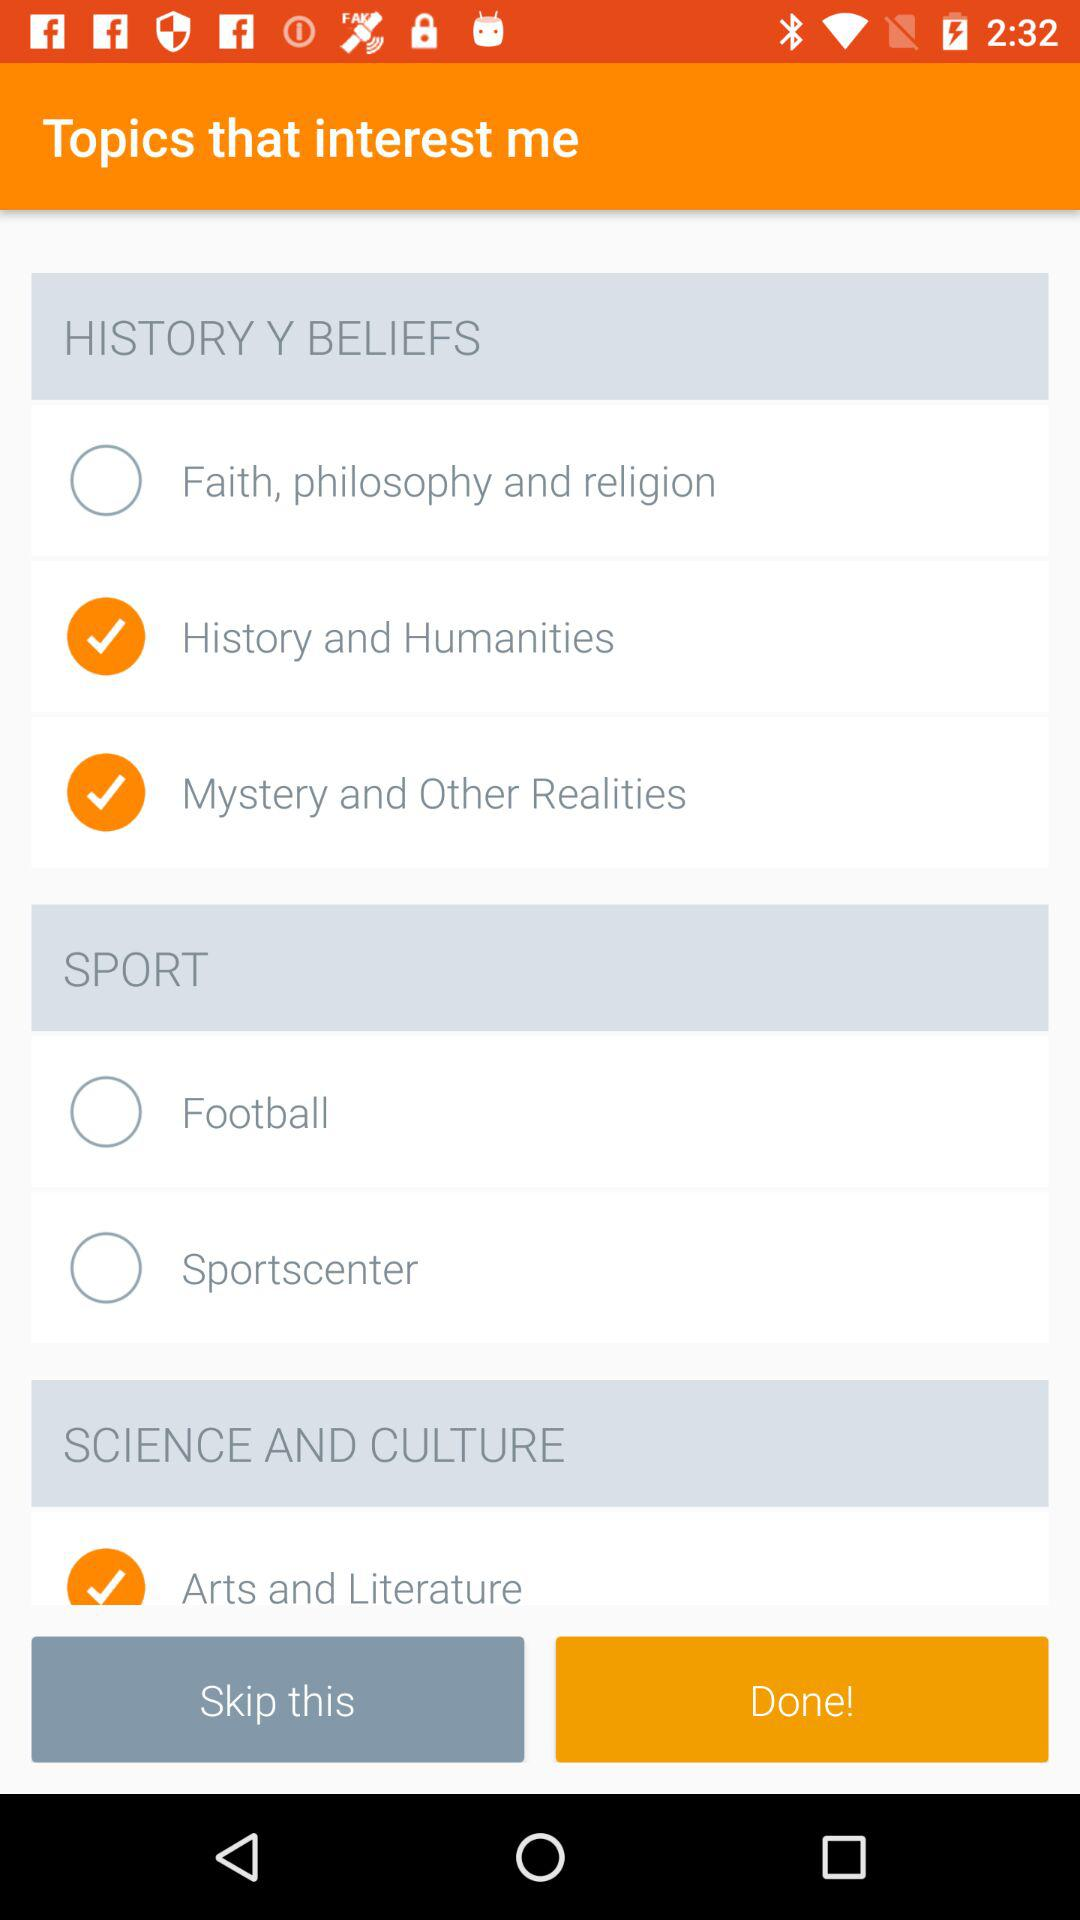What are the different sports? The different sports are "Football" and "Sportscenter". 